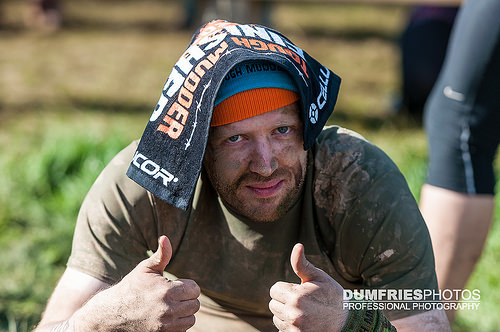<image>
Can you confirm if the towel is under the hat? No. The towel is not positioned under the hat. The vertical relationship between these objects is different. 